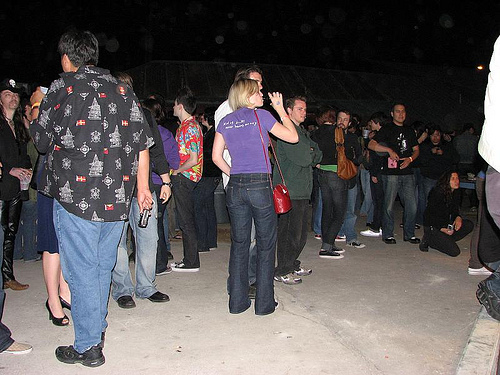<image>
Is there a man to the right of the machine? No. The man is not to the right of the machine. The horizontal positioning shows a different relationship. Is there a man in front of the woman? No. The man is not in front of the woman. The spatial positioning shows a different relationship between these objects. 